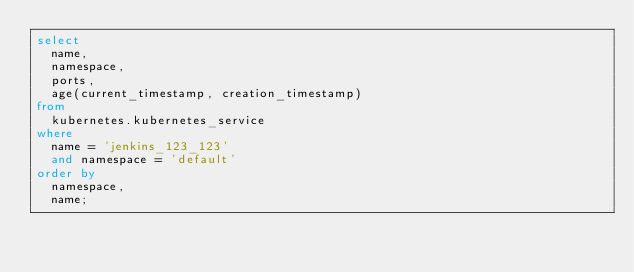<code> <loc_0><loc_0><loc_500><loc_500><_SQL_>select
  name,
  namespace,
  ports,
  age(current_timestamp, creation_timestamp)
from
  kubernetes.kubernetes_service
where
  name = 'jenkins_123_123'
  and namespace = 'default'
order by
  namespace,
  name;
</code> 